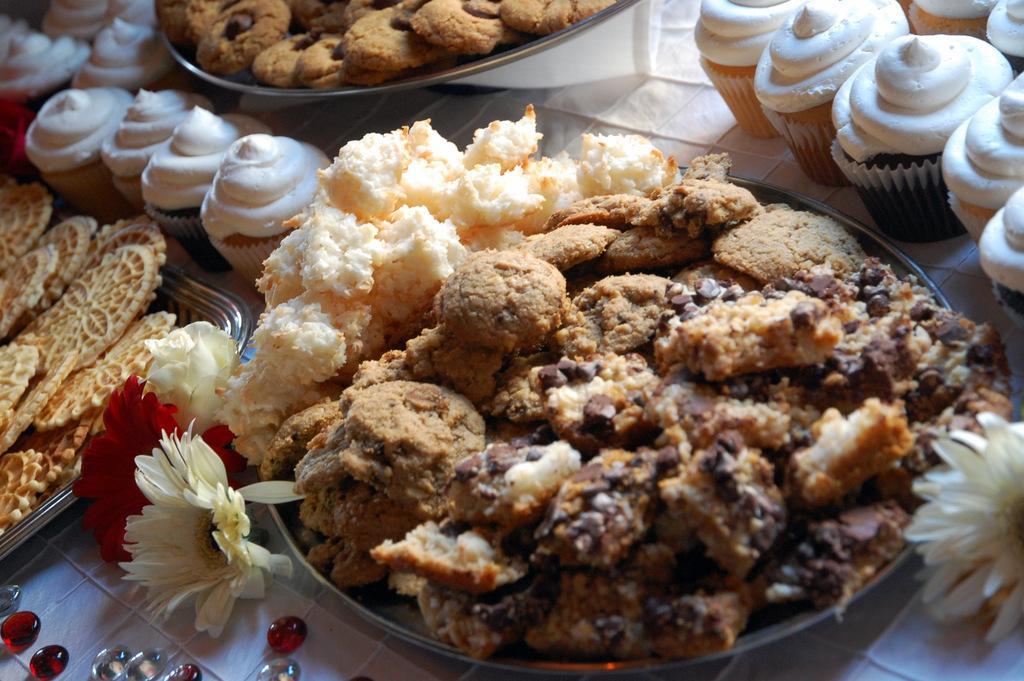How would you summarize this image in a sentence or two? In this image there are plates which contain various food items in it and these plates, cupcakes, flowers and beads are placed on a surface. 